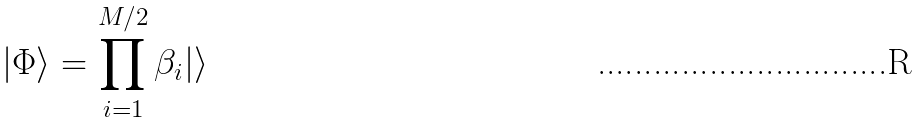<formula> <loc_0><loc_0><loc_500><loc_500>| \Phi \rangle = \prod _ { i = 1 } ^ { M / 2 } \beta _ { i } | \rangle</formula> 